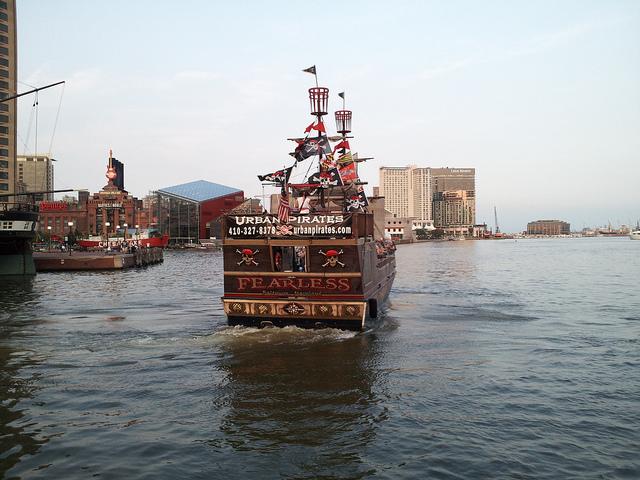Could this be a replica of a pirates ship?
Write a very short answer. Yes. Would the flags flown by this vessel have any meaning to the occupants of another ship?
Short answer required. Yes. Who can be found aboard that boat?
Keep it brief. Pirates. Is that a passengers boat?
Give a very brief answer. Yes. What is written on the boat?
Concise answer only. Urban pirates. 